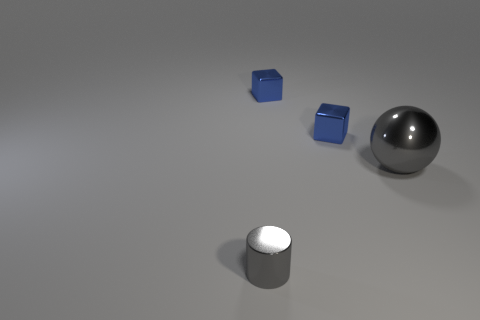How many gray things are both behind the cylinder and left of the ball?
Your answer should be compact. 0. There is a gray cylinder that is made of the same material as the gray ball; what size is it?
Your answer should be compact. Small. What is the size of the gray cylinder?
Give a very brief answer. Small. What material is the big gray sphere?
Give a very brief answer. Metal. There is a gray shiny thing that is behind the cylinder; does it have the same size as the cylinder?
Offer a terse response. No. How many objects are tiny gray metallic objects or gray balls?
Offer a terse response. 2. The metal thing that is the same color as the metal cylinder is what shape?
Your response must be concise. Sphere. How many tiny gray shiny things are there?
Make the answer very short. 1. How many cylinders are big things or gray metal objects?
Make the answer very short. 1. There is a tiny metallic object in front of the gray thing that is on the right side of the small gray object; what number of objects are on the left side of it?
Give a very brief answer. 0. 